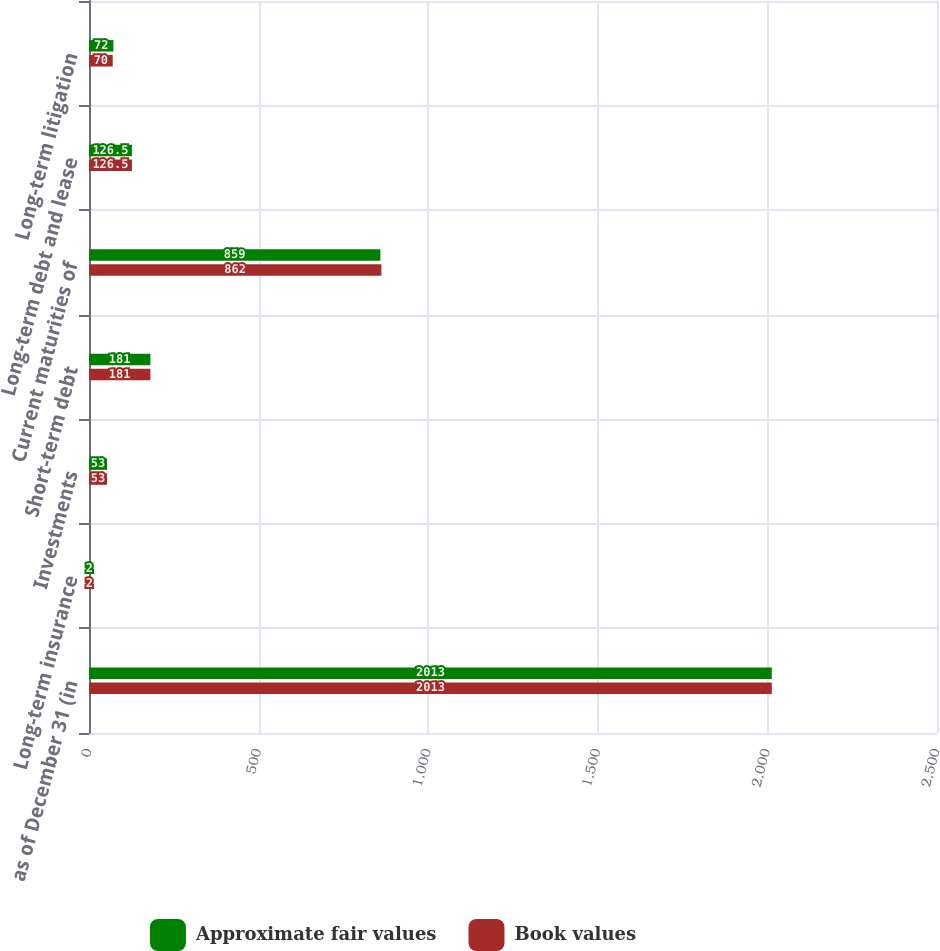Convert chart to OTSL. <chart><loc_0><loc_0><loc_500><loc_500><stacked_bar_chart><ecel><fcel>as of December 31 (in<fcel>Long-term insurance<fcel>Investments<fcel>Short-term debt<fcel>Current maturities of<fcel>Long-term debt and lease<fcel>Long-term litigation<nl><fcel>Approximate fair values<fcel>2013<fcel>2<fcel>53<fcel>181<fcel>859<fcel>126.5<fcel>72<nl><fcel>Book values<fcel>2013<fcel>2<fcel>53<fcel>181<fcel>862<fcel>126.5<fcel>70<nl></chart> 